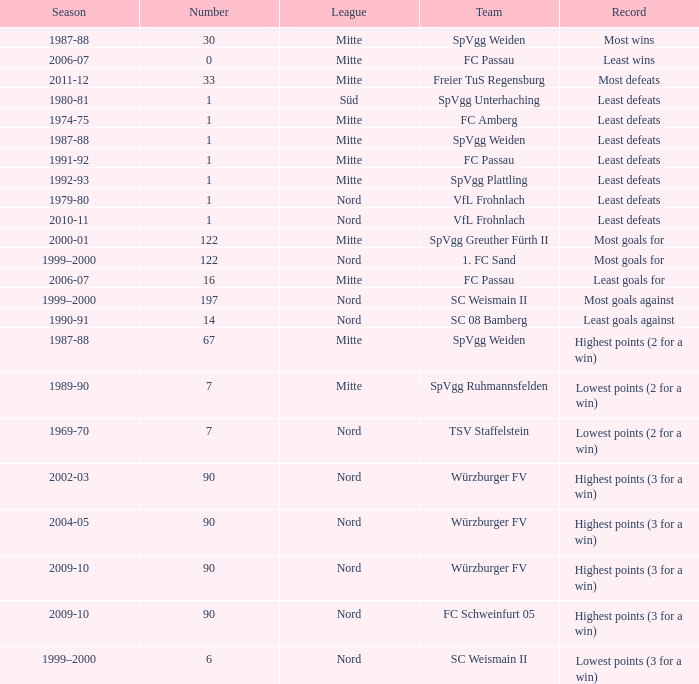What league has most wins as the record? Mitte. 